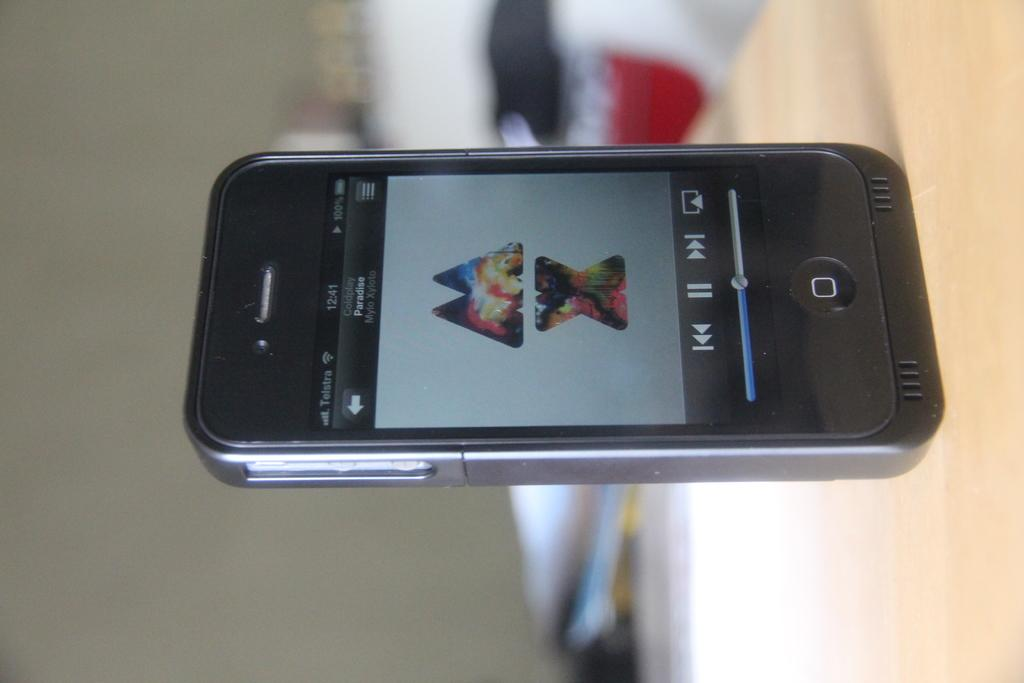<image>
Offer a succinct explanation of the picture presented. a black upright iphone with the song Paradise from Coldplay playing 